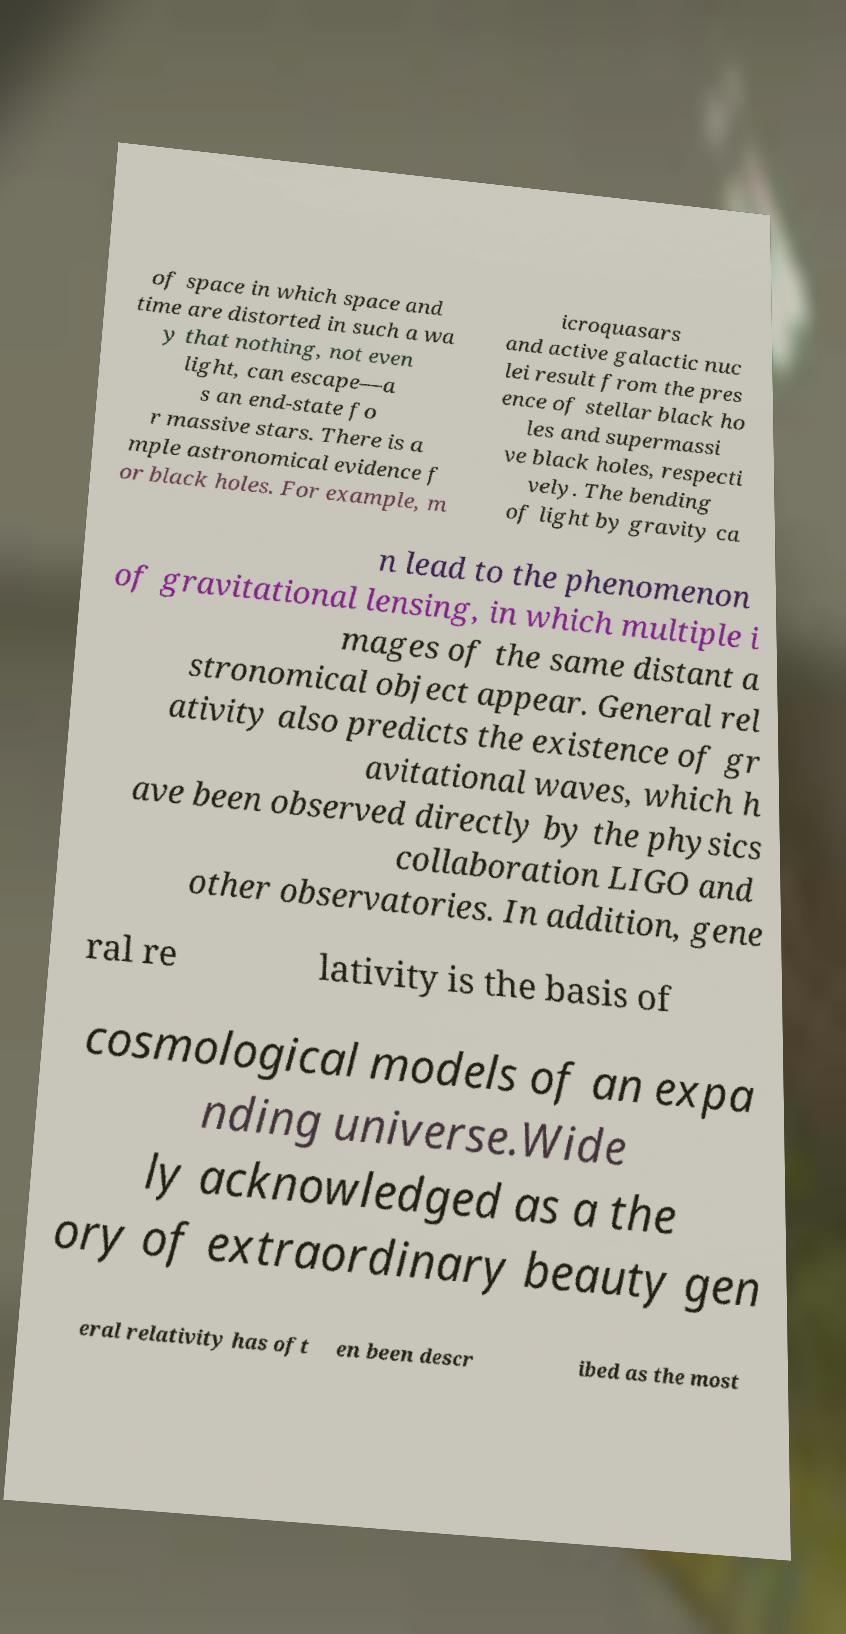Please identify and transcribe the text found in this image. of space in which space and time are distorted in such a wa y that nothing, not even light, can escape—a s an end-state fo r massive stars. There is a mple astronomical evidence f or black holes. For example, m icroquasars and active galactic nuc lei result from the pres ence of stellar black ho les and supermassi ve black holes, respecti vely. The bending of light by gravity ca n lead to the phenomenon of gravitational lensing, in which multiple i mages of the same distant a stronomical object appear. General rel ativity also predicts the existence of gr avitational waves, which h ave been observed directly by the physics collaboration LIGO and other observatories. In addition, gene ral re lativity is the basis of cosmological models of an expa nding universe.Wide ly acknowledged as a the ory of extraordinary beauty gen eral relativity has oft en been descr ibed as the most 